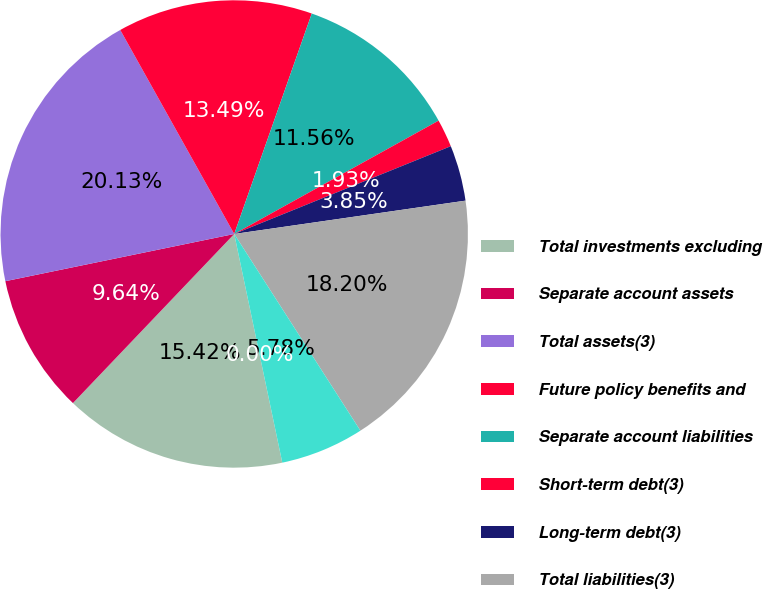Convert chart to OTSL. <chart><loc_0><loc_0><loc_500><loc_500><pie_chart><fcel>Total investments excluding<fcel>Separate account assets<fcel>Total assets(3)<fcel>Future policy benefits and<fcel>Separate account liabilities<fcel>Short-term debt(3)<fcel>Long-term debt(3)<fcel>Total liabilities(3)<fcel>Prudential Financial Inc<fcel>Noncontrolling interests<nl><fcel>15.42%<fcel>9.64%<fcel>20.13%<fcel>13.49%<fcel>11.56%<fcel>1.93%<fcel>3.85%<fcel>18.2%<fcel>5.78%<fcel>0.0%<nl></chart> 